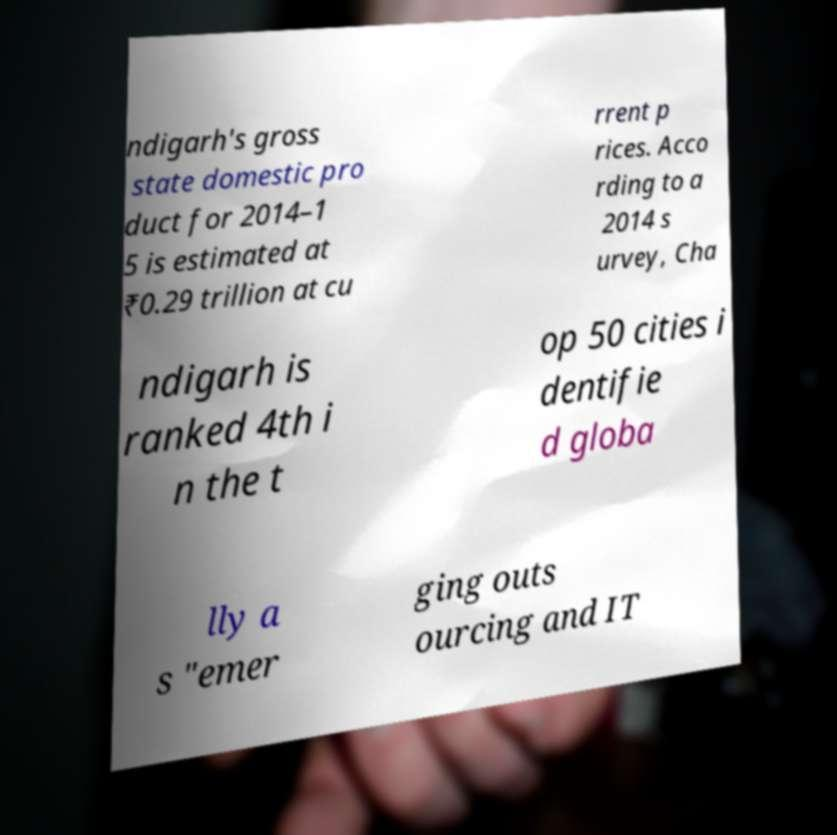Please identify and transcribe the text found in this image. ndigarh's gross state domestic pro duct for 2014–1 5 is estimated at ₹0.29 trillion at cu rrent p rices. Acco rding to a 2014 s urvey, Cha ndigarh is ranked 4th i n the t op 50 cities i dentifie d globa lly a s "emer ging outs ourcing and IT 